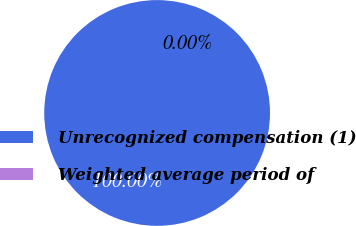<chart> <loc_0><loc_0><loc_500><loc_500><pie_chart><fcel>Unrecognized compensation (1)<fcel>Weighted average period of<nl><fcel>100.0%<fcel>0.0%<nl></chart> 